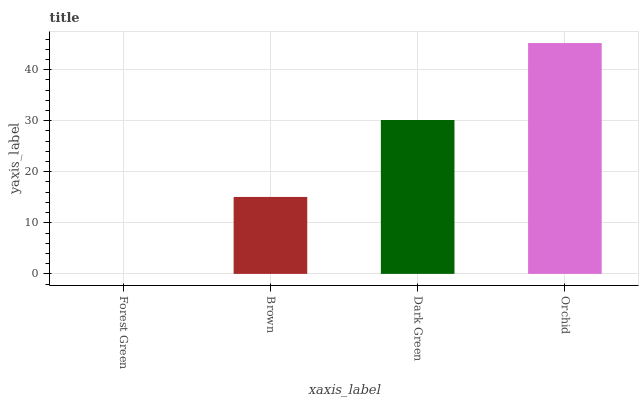Is Brown the minimum?
Answer yes or no. No. Is Brown the maximum?
Answer yes or no. No. Is Brown greater than Forest Green?
Answer yes or no. Yes. Is Forest Green less than Brown?
Answer yes or no. Yes. Is Forest Green greater than Brown?
Answer yes or no. No. Is Brown less than Forest Green?
Answer yes or no. No. Is Dark Green the high median?
Answer yes or no. Yes. Is Brown the low median?
Answer yes or no. Yes. Is Forest Green the high median?
Answer yes or no. No. Is Forest Green the low median?
Answer yes or no. No. 